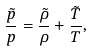Convert formula to latex. <formula><loc_0><loc_0><loc_500><loc_500>\frac { \tilde { p } } { p } = \frac { \tilde { \rho } } { \rho } + \frac { \tilde { T } } { T } ,</formula> 